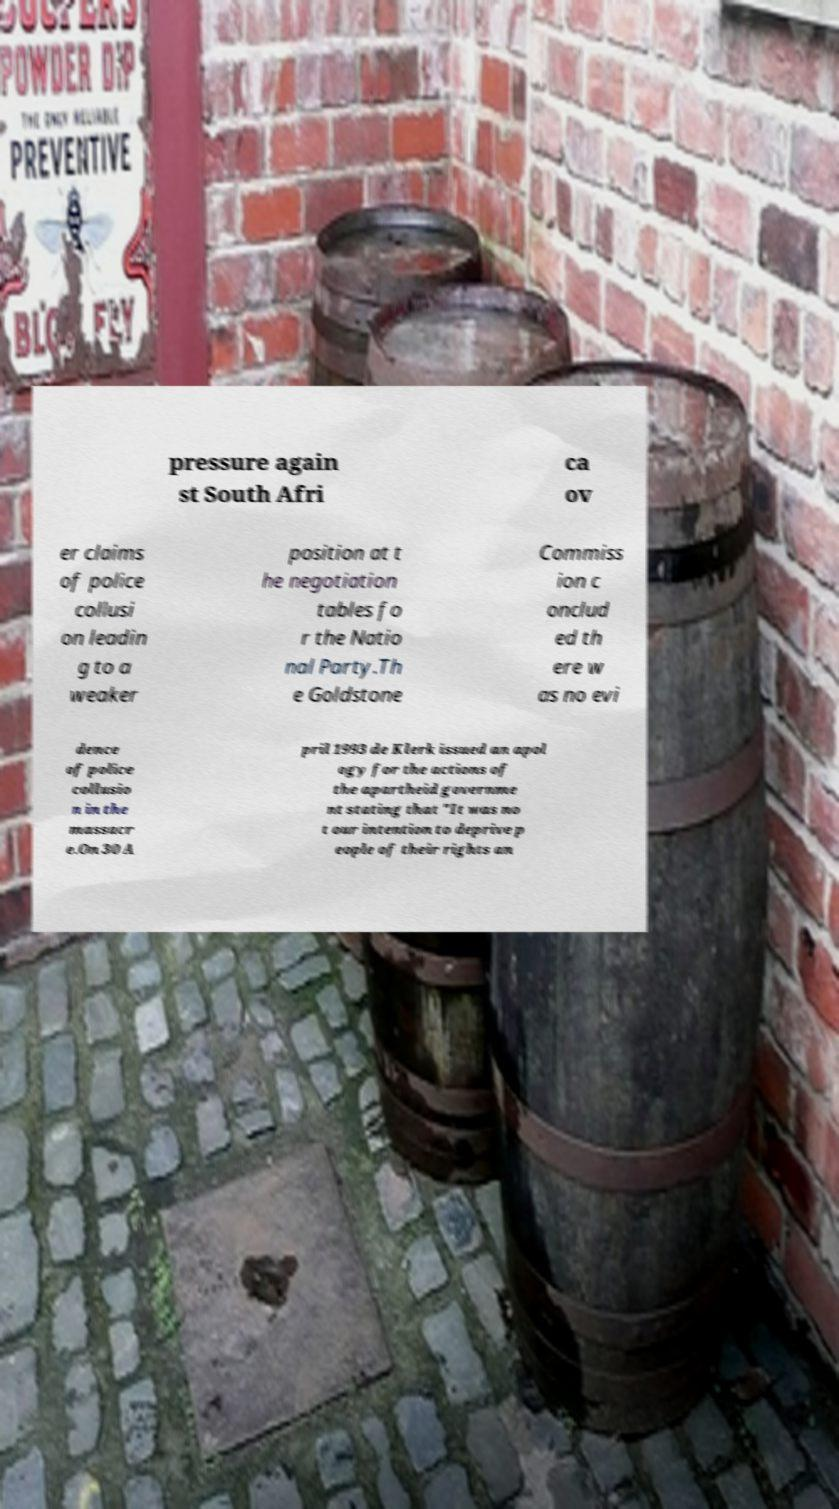Please read and relay the text visible in this image. What does it say? pressure again st South Afri ca ov er claims of police collusi on leadin g to a weaker position at t he negotiation tables fo r the Natio nal Party.Th e Goldstone Commiss ion c onclud ed th ere w as no evi dence of police collusio n in the massacr e.On 30 A pril 1993 de Klerk issued an apol ogy for the actions of the apartheid governme nt stating that "It was no t our intention to deprive p eople of their rights an 